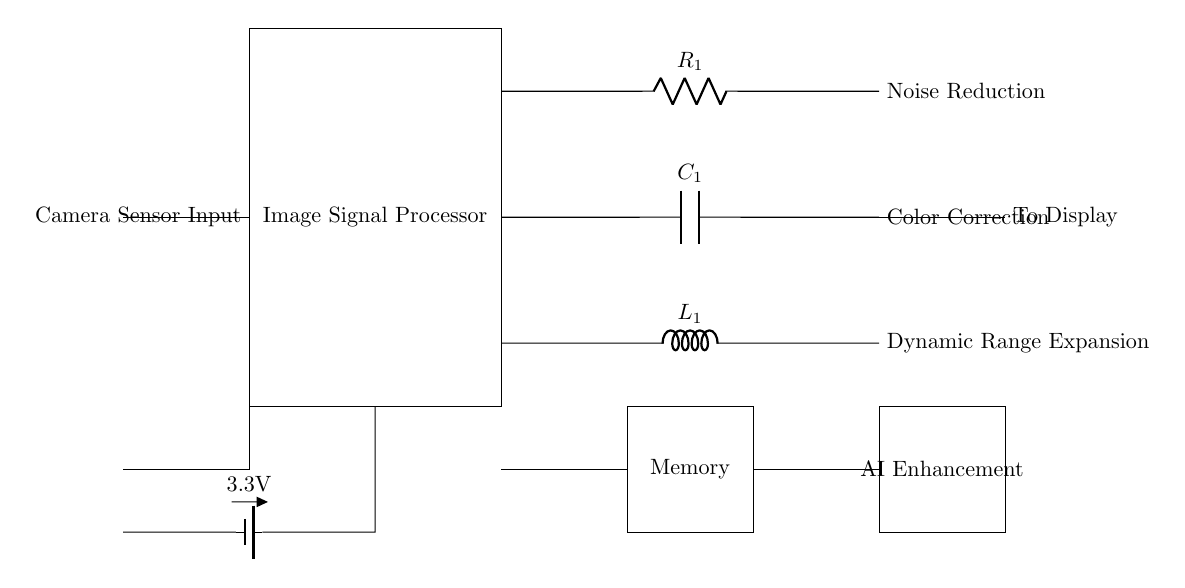What is the main component of this circuit? The main component, represented by the largest rectangle, is the Image Signal Processor, which is responsible for processing the input from the camera sensor.
Answer: Image Signal Processor What type of component is used for noise reduction? The component used for noise reduction is a resistor, denoted as R1. Resistors in circuits typically help manage or limit noise, improving signal quality.
Answer: Resistor How many main processing functions are represented in this circuit? There are three main processing functions: Noise Reduction, Color Correction, and Dynamic Range Expansion, which are crucial for enhancing image quality.
Answer: Three What is the voltage supply for the circuit? The circuit is powered by a battery supplying a voltage of 3.3 volts, indicating the operating voltage for functional components.
Answer: 3.3V Which component is responsible for AI enhancements? The component labeled as "AI Enhancement" is a dedicated block for processing data using artificial intelligence algorithms to improve image clarity and features.
Answer: AI Enhancement How is the clock for the circuit generated? The clock is generated using an oscillator, which provides timing signals necessary for synchronous operation within the circuit.
Answer: Oscillator What does the circuit output to? The processed signals from the Image Signal Processor are output to a display component, where the enhanced images are presented to the user.
Answer: To Display 